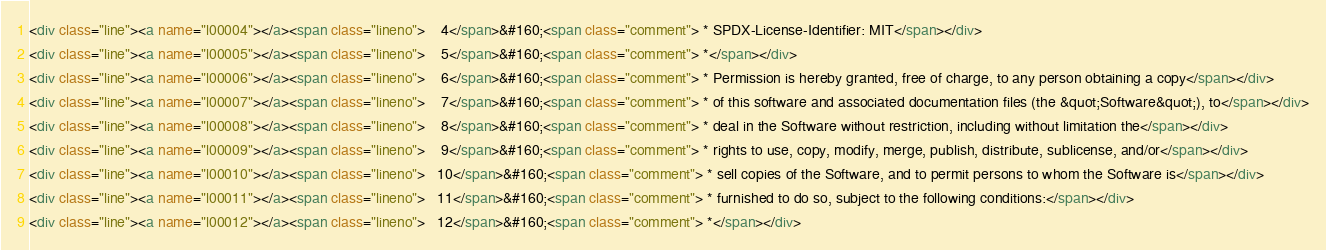Convert code to text. <code><loc_0><loc_0><loc_500><loc_500><_HTML_><div class="line"><a name="l00004"></a><span class="lineno">    4</span>&#160;<span class="comment"> * SPDX-License-Identifier: MIT</span></div>
<div class="line"><a name="l00005"></a><span class="lineno">    5</span>&#160;<span class="comment"> *</span></div>
<div class="line"><a name="l00006"></a><span class="lineno">    6</span>&#160;<span class="comment"> * Permission is hereby granted, free of charge, to any person obtaining a copy</span></div>
<div class="line"><a name="l00007"></a><span class="lineno">    7</span>&#160;<span class="comment"> * of this software and associated documentation files (the &quot;Software&quot;), to</span></div>
<div class="line"><a name="l00008"></a><span class="lineno">    8</span>&#160;<span class="comment"> * deal in the Software without restriction, including without limitation the</span></div>
<div class="line"><a name="l00009"></a><span class="lineno">    9</span>&#160;<span class="comment"> * rights to use, copy, modify, merge, publish, distribute, sublicense, and/or</span></div>
<div class="line"><a name="l00010"></a><span class="lineno">   10</span>&#160;<span class="comment"> * sell copies of the Software, and to permit persons to whom the Software is</span></div>
<div class="line"><a name="l00011"></a><span class="lineno">   11</span>&#160;<span class="comment"> * furnished to do so, subject to the following conditions:</span></div>
<div class="line"><a name="l00012"></a><span class="lineno">   12</span>&#160;<span class="comment"> *</span></div></code> 